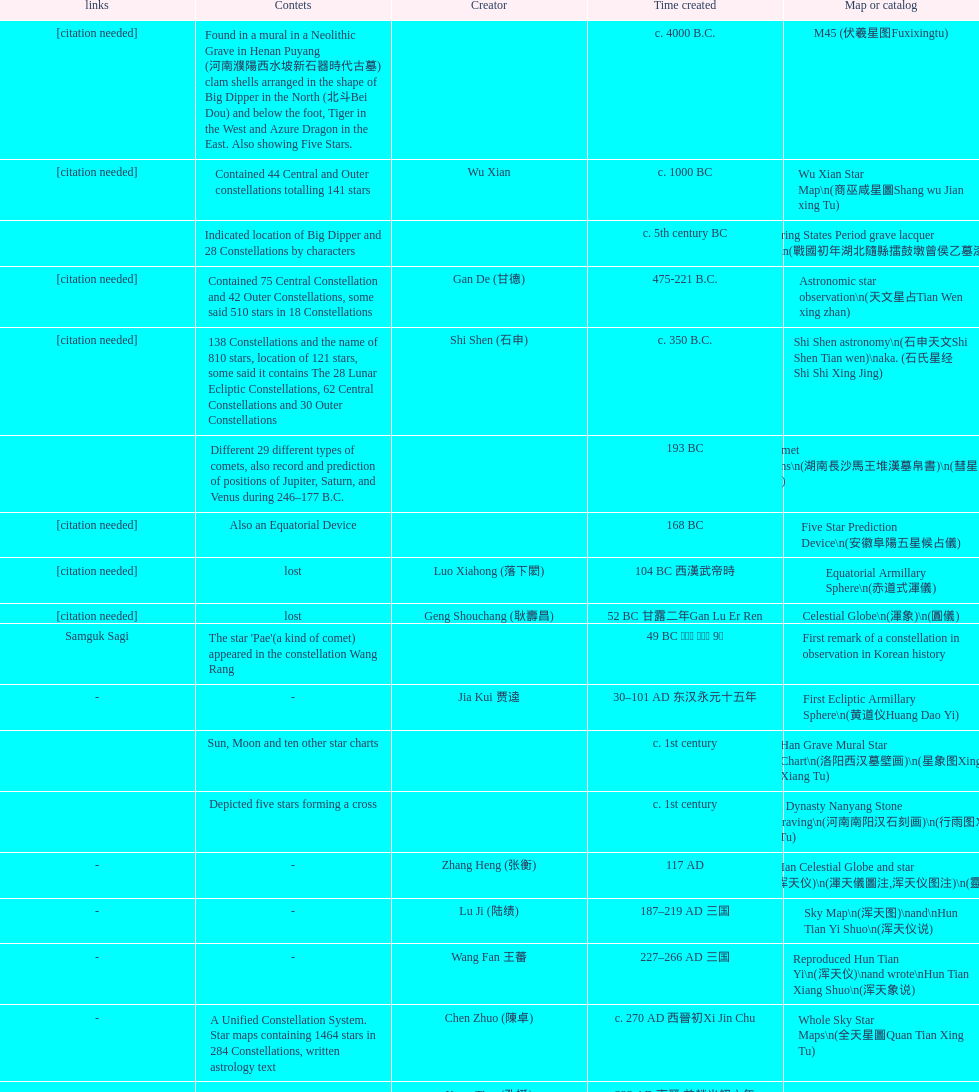Did xu guang ci or su song create the five star charts in 1094 ad? Su Song 蘇頌. 